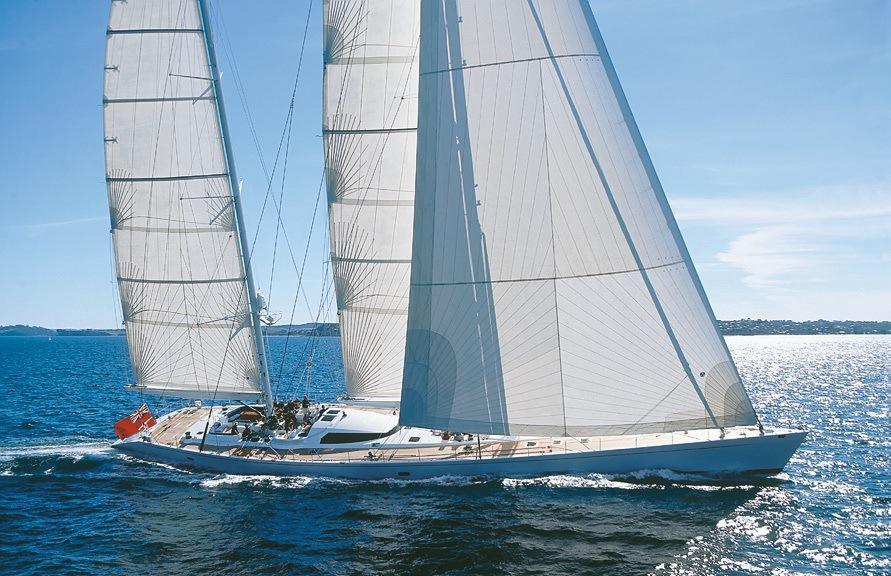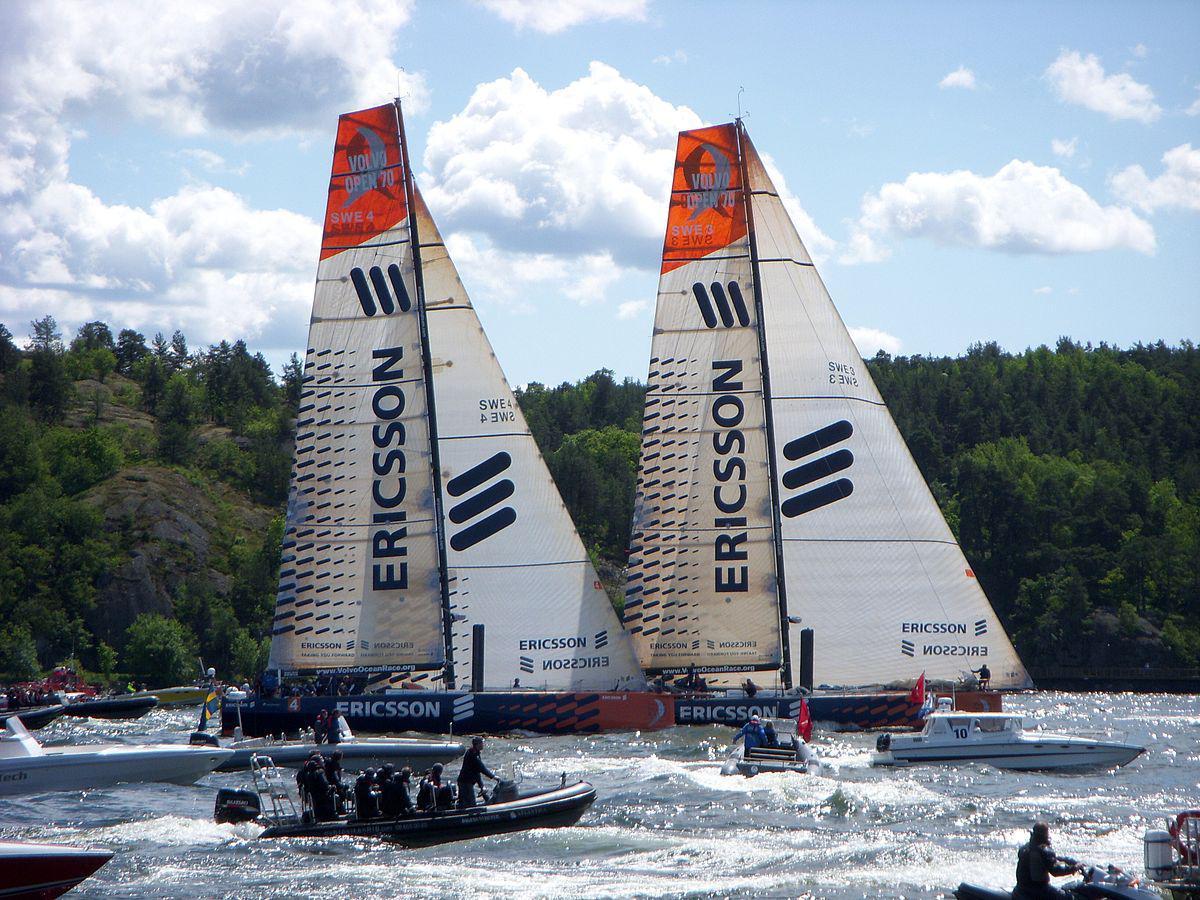The first image is the image on the left, the second image is the image on the right. Evaluate the accuracy of this statement regarding the images: "In at least one image there is a white boat facing right sailing on the water.". Is it true? Answer yes or no. Yes. The first image is the image on the left, the second image is the image on the right. Analyze the images presented: Is the assertion "There is just one sailboat in one of the images, but the other has at least three sailboats." valid? Answer yes or no. No. 